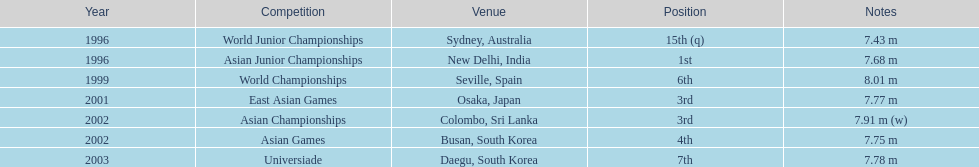What is the difference between the number of times the position of third was achieved and the number of times the position of first was achieved? 1. 